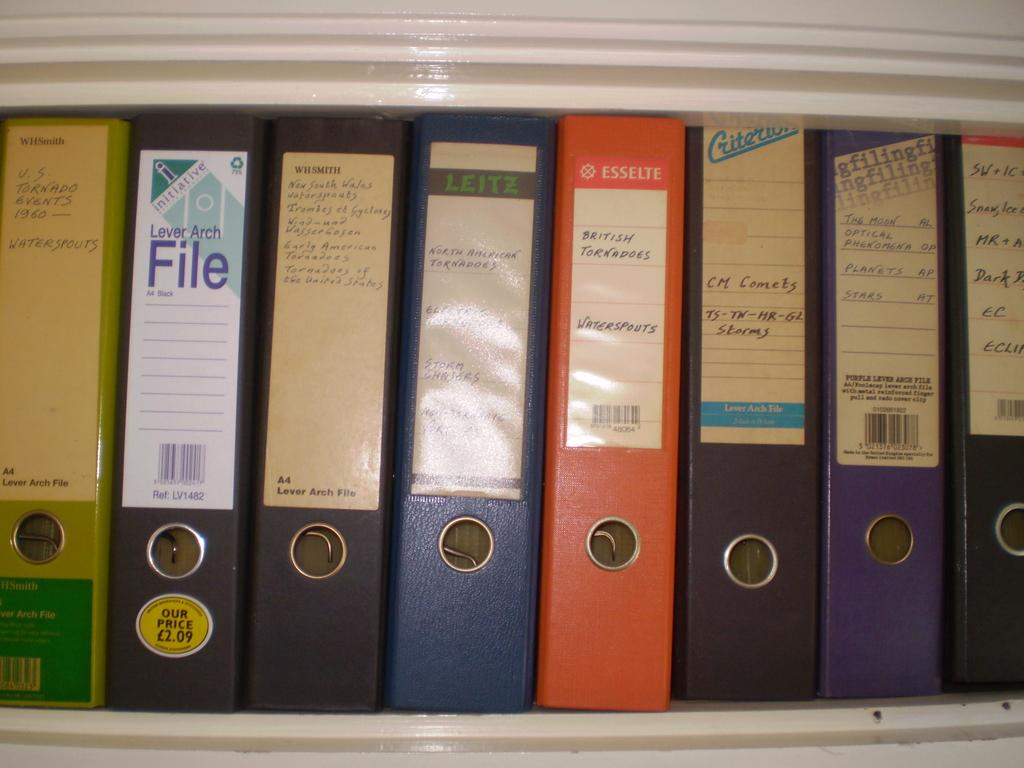What objects can be seen in the image? There are files in the image. How are the files organized in the image? The files are arranged in a shelf. What is the color of the shelf in the image? The shelf is white in color. What type of metal can be seen in the image? There is no metal present in the image; it features files arranged on a white shelf. What advice can be given based on the image? The image does not provide any advice, as it only shows files arranged on a shelf. 